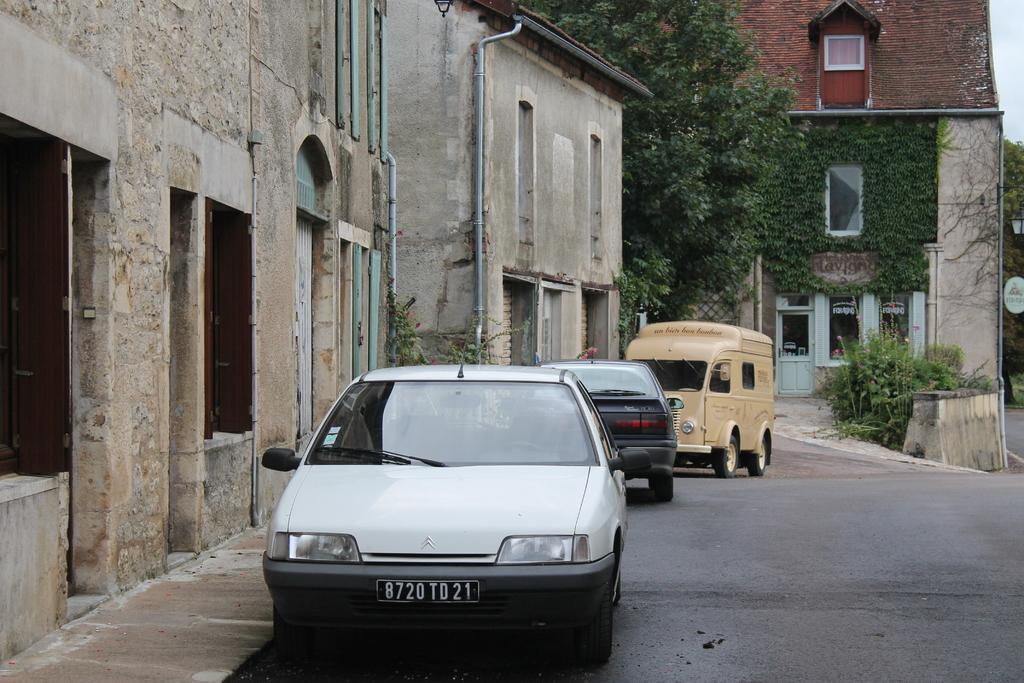Describe this image in one or two sentences. In this image we can see these vehicles are parked on the side of the road. Here we can see stone buildings, pipes, trees, plants, lights poles, wooden house and the sky in the background. 